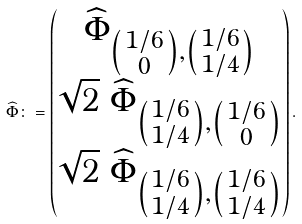Convert formula to latex. <formula><loc_0><loc_0><loc_500><loc_500>\widehat { \Phi } \colon = \begin{pmatrix} \widehat { \Phi } _ { \left ( \begin{smallmatrix} 1 / 6 \\ 0 \end{smallmatrix} \right ) , \left ( \begin{smallmatrix} 1 / 6 \\ 1 / 4 \end{smallmatrix} \right ) } \\ \sqrt { 2 } \ \widehat { \Phi } _ { \left ( \begin{smallmatrix} 1 / 6 \\ 1 / 4 \end{smallmatrix} \right ) , \left ( \begin{smallmatrix} 1 / 6 \\ 0 \end{smallmatrix} \right ) } \\ \sqrt { 2 } \ \widehat { \Phi } _ { \left ( \begin{smallmatrix} 1 / 6 \\ 1 / 4 \end{smallmatrix} \right ) , \left ( \begin{smallmatrix} 1 / 6 \\ 1 / 4 \end{smallmatrix} \right ) } \end{pmatrix} .</formula> 